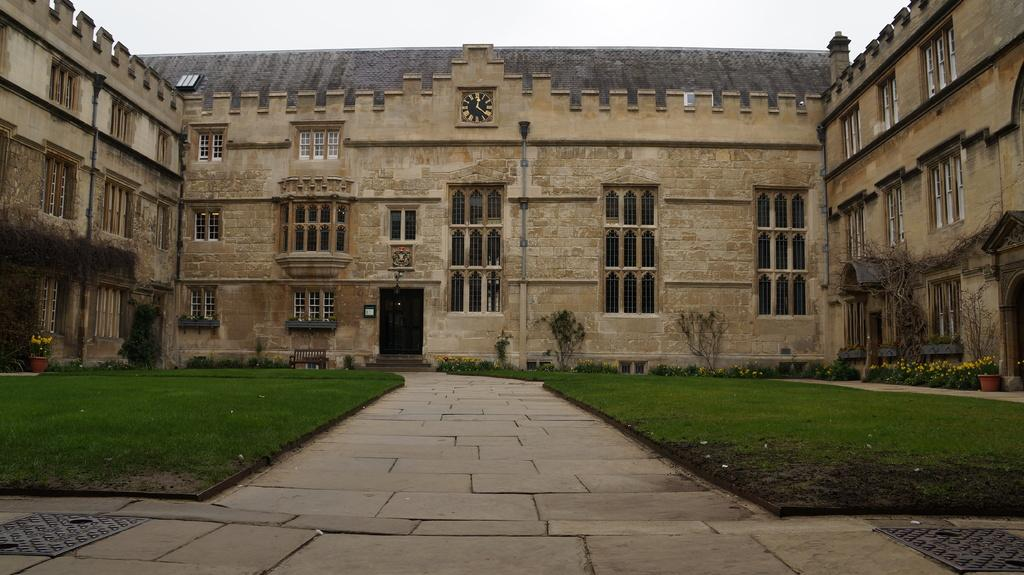What can be found on the ground in the image? There are manholes on the ground in the image. What type of vegetation is present in the image? There are trees, house plants with flowers, and plants in the image. What type of ground cover is visible in the image? There is grass in the image. What type of seating is available in the image? There is a bench in the image. What can be seen in the background of the image? There is a building and sky visible in the background of the image. What brand of toothpaste is advertised on the building in the image? There is no toothpaste advertised on the building in the image; it is a building in the background. How many feet are visible in the image? There are no feet visible in the image. 